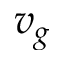Convert formula to latex. <formula><loc_0><loc_0><loc_500><loc_500>v _ { g }</formula> 